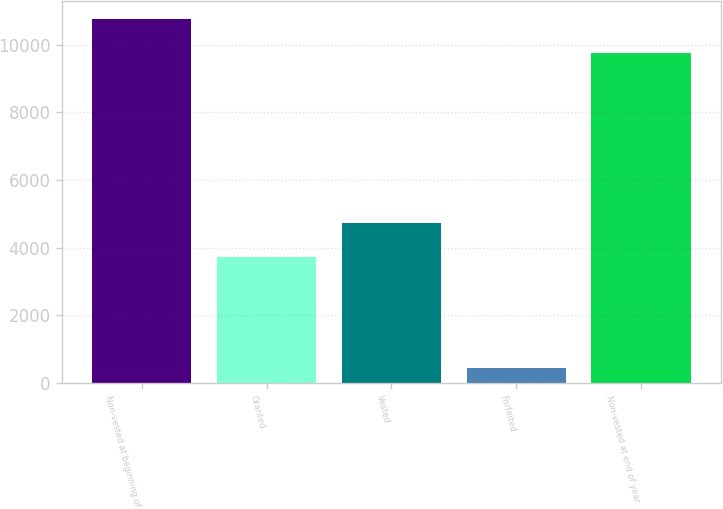Convert chart. <chart><loc_0><loc_0><loc_500><loc_500><bar_chart><fcel>Non-vested at beginning of<fcel>Granted<fcel>Vested<fcel>Forfeited<fcel>Non-vested at end of year<nl><fcel>10758<fcel>3714<fcel>4713<fcel>442<fcel>9759<nl></chart> 